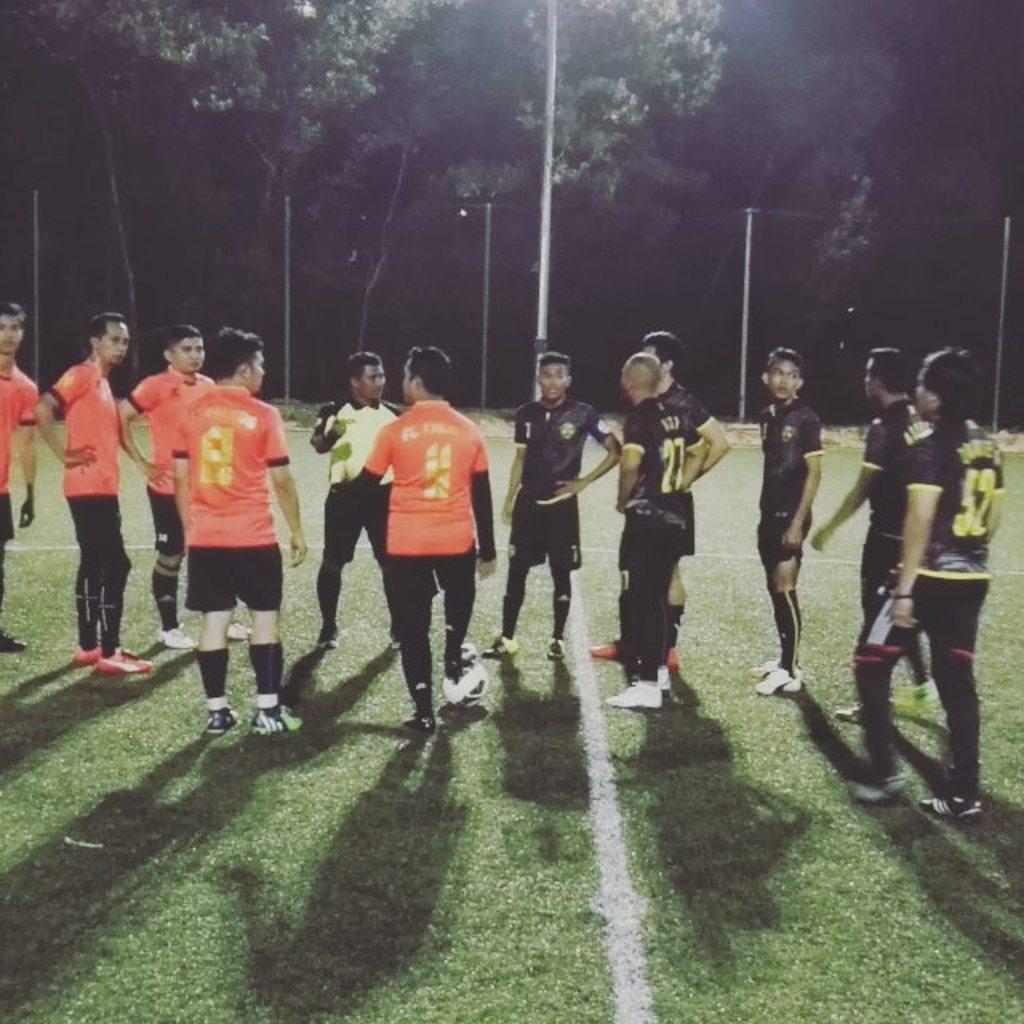Could you give a brief overview of what you see in this image? As we can see in the image there are group of people standing here and there. The people on the left side are wearing orange color dresses and the group of people on the right side are wearing black color dresses. There is grass and trees. 